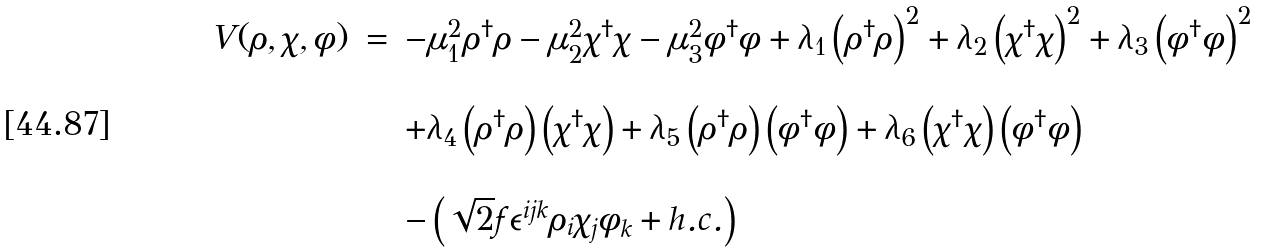<formula> <loc_0><loc_0><loc_500><loc_500>\begin{array} { c c l } V ( \rho , \chi , \phi ) & = & - \mu _ { 1 } ^ { 2 } \rho ^ { \dagger } \rho - \mu _ { 2 } ^ { 2 } \chi ^ { \dagger } \chi - \mu _ { 3 } ^ { 2 } \phi ^ { \dagger } \phi + \lambda _ { 1 } \left ( \rho ^ { \dagger } \rho \right ) ^ { 2 } + \lambda _ { 2 } \left ( \chi ^ { \dagger } \chi \right ) ^ { 2 } + \lambda _ { 3 } \left ( \phi ^ { \dagger } \phi \right ) ^ { 2 } \\ \\ & & + \lambda _ { 4 } \left ( \rho ^ { \dagger } \rho \right ) \left ( \chi ^ { \dagger } \chi \right ) + \lambda _ { 5 } \left ( \rho ^ { \dagger } \rho \right ) \left ( \phi ^ { \dagger } \phi \right ) + \lambda _ { 6 } \left ( \chi ^ { \dagger } \chi \right ) \left ( \phi ^ { \dagger } \phi \right ) \\ \\ & & - \left ( \sqrt { 2 } f \epsilon ^ { i j k } \rho _ { i } \chi _ { j } \phi _ { k } + h . c . \right ) \end{array}</formula> 